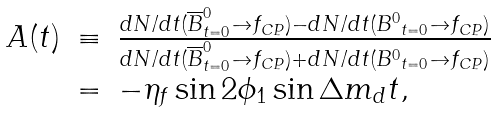Convert formula to latex. <formula><loc_0><loc_0><loc_500><loc_500>\begin{array} { l c l } A ( t ) & \equiv & \frac { d N / d t ( \overline { B } ^ { 0 } _ { t = 0 } \to f _ { C P } ) - d N / d t ( { B ^ { 0 } } _ { t = 0 } \to f _ { C P } ) } { d N / d t ( \overline { B } ^ { 0 } _ { t = 0 } \to f _ { C P } ) + d N / d t ( { B ^ { 0 } } _ { t = 0 } \to f _ { C P } ) } \\ & = & - \eta _ { f } \sin 2 \phi _ { 1 } \sin \Delta m _ { d } t , \end{array}</formula> 